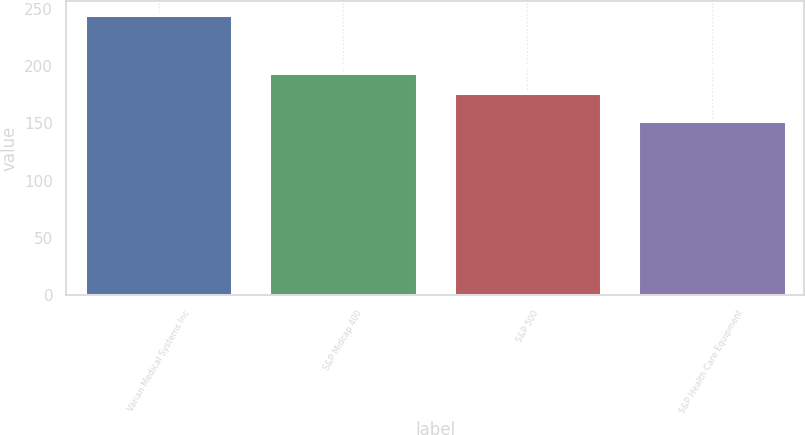<chart> <loc_0><loc_0><loc_500><loc_500><bar_chart><fcel>Varian Medical Systems Inc<fcel>S&P Midcap 400<fcel>S&P 500<fcel>S&P Health Care Equipment<nl><fcel>244.46<fcel>194.05<fcel>176.17<fcel>152.06<nl></chart> 